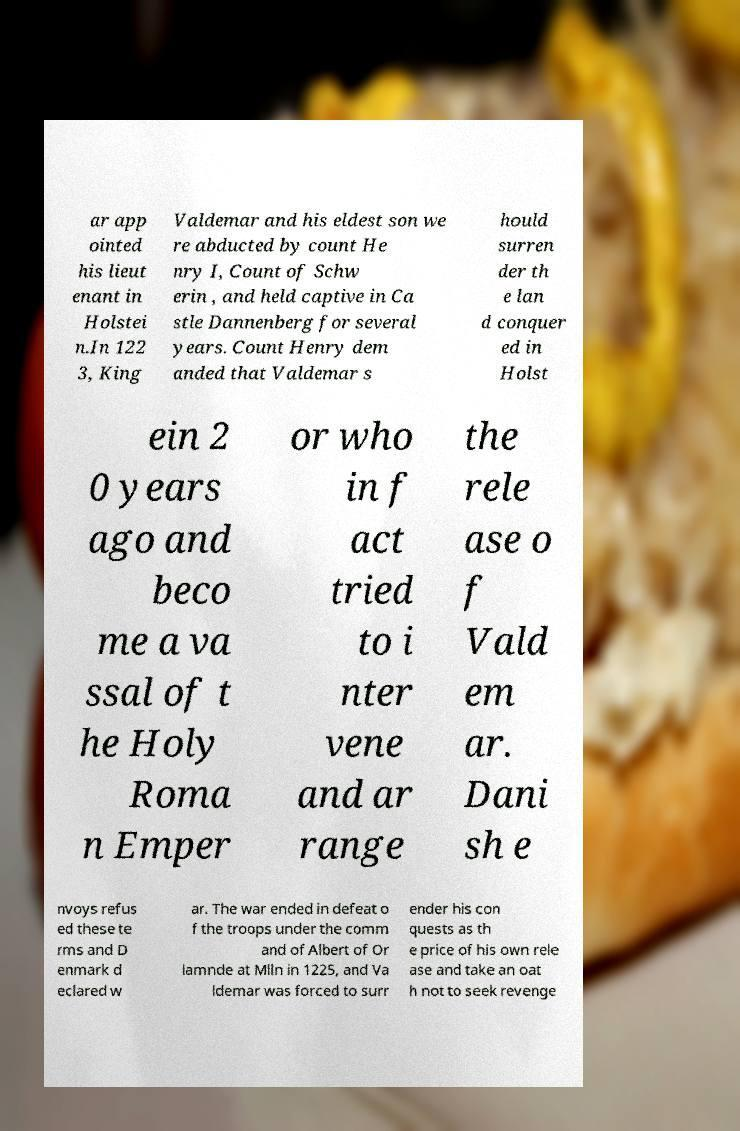For documentation purposes, I need the text within this image transcribed. Could you provide that? ar app ointed his lieut enant in Holstei n.In 122 3, King Valdemar and his eldest son we re abducted by count He nry I, Count of Schw erin , and held captive in Ca stle Dannenberg for several years. Count Henry dem anded that Valdemar s hould surren der th e lan d conquer ed in Holst ein 2 0 years ago and beco me a va ssal of t he Holy Roma n Emper or who in f act tried to i nter vene and ar range the rele ase o f Vald em ar. Dani sh e nvoys refus ed these te rms and D enmark d eclared w ar. The war ended in defeat o f the troops under the comm and of Albert of Or lamnde at Mlln in 1225, and Va ldemar was forced to surr ender his con quests as th e price of his own rele ase and take an oat h not to seek revenge 